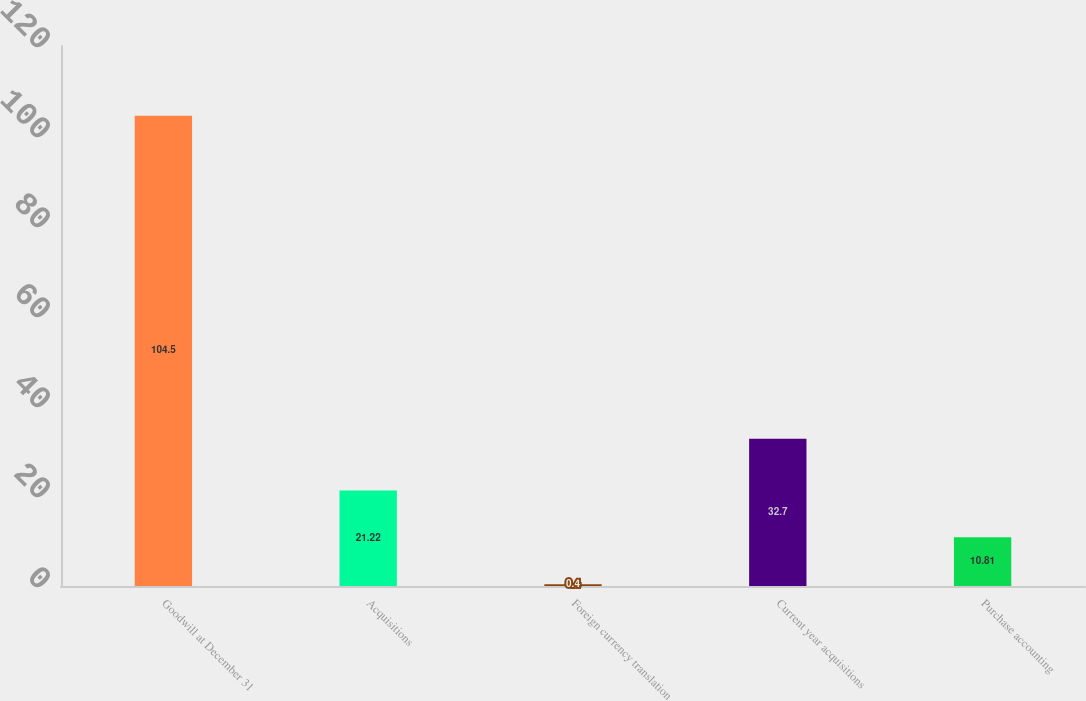<chart> <loc_0><loc_0><loc_500><loc_500><bar_chart><fcel>Goodwill at December 31<fcel>Acquisitions<fcel>Foreign currency translation<fcel>Current year acquisitions<fcel>Purchase accounting<nl><fcel>104.5<fcel>21.22<fcel>0.4<fcel>32.7<fcel>10.81<nl></chart> 